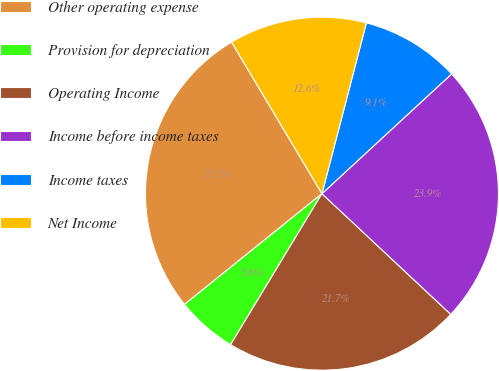<chart> <loc_0><loc_0><loc_500><loc_500><pie_chart><fcel>Other operating expense<fcel>Provision for depreciation<fcel>Operating Income<fcel>Income before income taxes<fcel>Income taxes<fcel>Net Income<nl><fcel>27.23%<fcel>5.55%<fcel>21.68%<fcel>23.85%<fcel>9.08%<fcel>12.61%<nl></chart> 